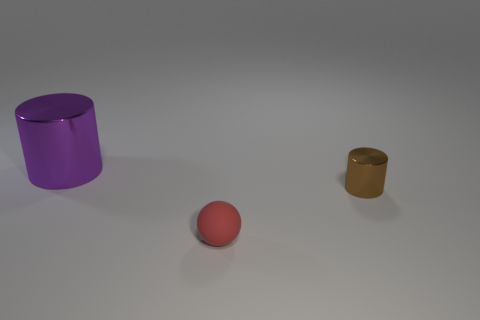Add 1 small brown cylinders. How many objects exist? 4 Subtract all cylinders. How many objects are left? 1 Add 2 cyan things. How many cyan things exist? 2 Subtract 0 red cylinders. How many objects are left? 3 Subtract all big objects. Subtract all brown things. How many objects are left? 1 Add 2 matte spheres. How many matte spheres are left? 3 